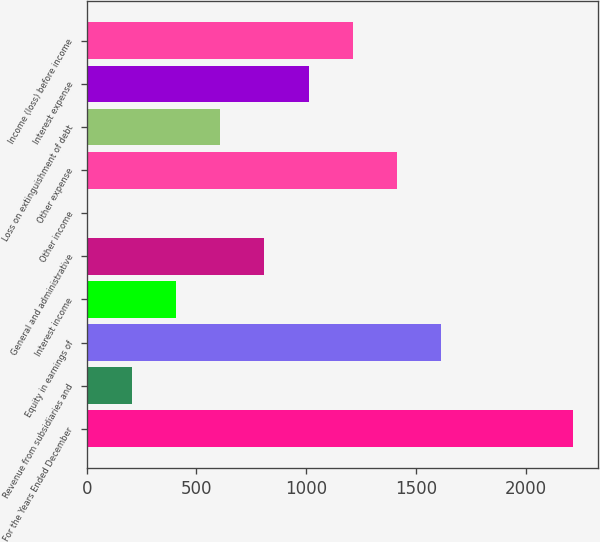Convert chart. <chart><loc_0><loc_0><loc_500><loc_500><bar_chart><fcel>For the Years Ended December<fcel>Revenue from subsidiaries and<fcel>Equity in earnings of<fcel>Interest income<fcel>General and administrative<fcel>Other income<fcel>Other expense<fcel>Loss on extinguishment of debt<fcel>Interest expense<fcel>Income (loss) before income<nl><fcel>2218.2<fcel>206.2<fcel>1614.6<fcel>407.4<fcel>809.8<fcel>5<fcel>1413.4<fcel>608.6<fcel>1011<fcel>1212.2<nl></chart> 